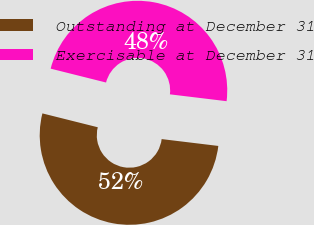Convert chart. <chart><loc_0><loc_0><loc_500><loc_500><pie_chart><fcel>Outstanding at December 31<fcel>Exercisable at December 31<nl><fcel>51.99%<fcel>48.01%<nl></chart> 